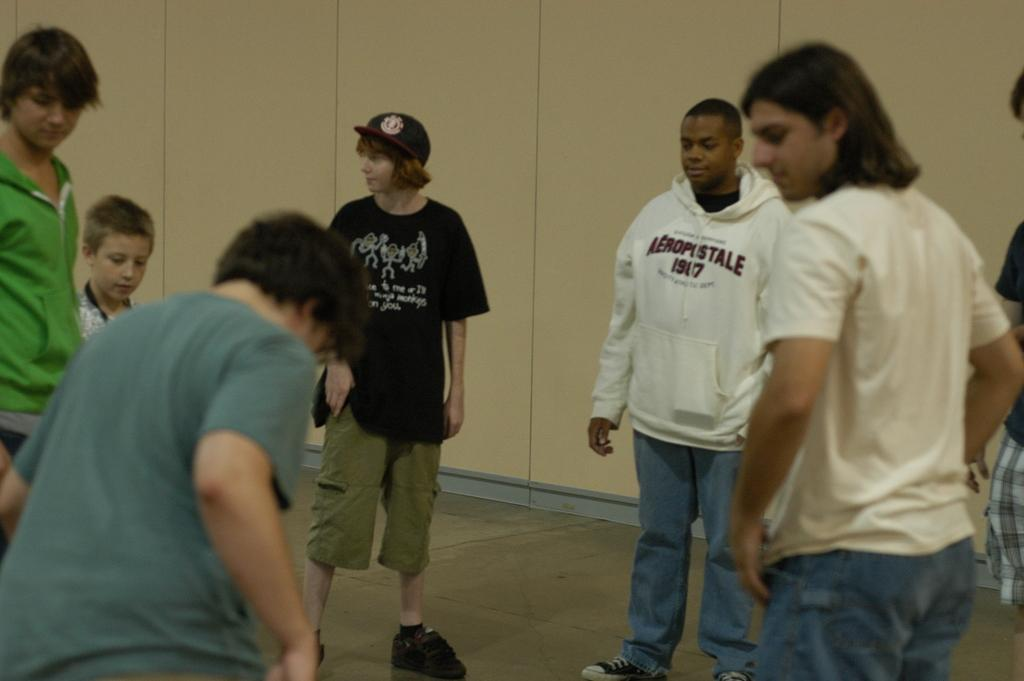What can be seen in the image? There are people standing in the image. Where are the people standing? The people are standing on the floor. What can be seen in the background of the image? There are walls visible in the background of the image. What type of vegetable is being used as a piggy bank in the image? There is no vegetable or piggy bank present in the image. 